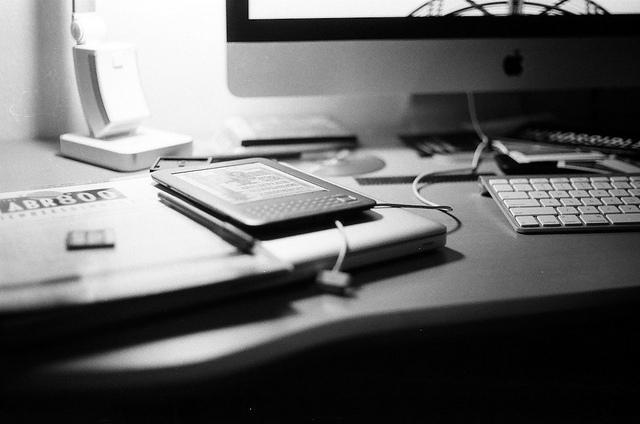How many people are wearing hat?
Give a very brief answer. 0. 